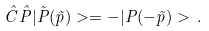Convert formula to latex. <formula><loc_0><loc_0><loc_500><loc_500>\hat { C } \hat { P } | \tilde { P } ( \vec { p } ) > = - | P ( - \vec { p } ) > \, .</formula> 